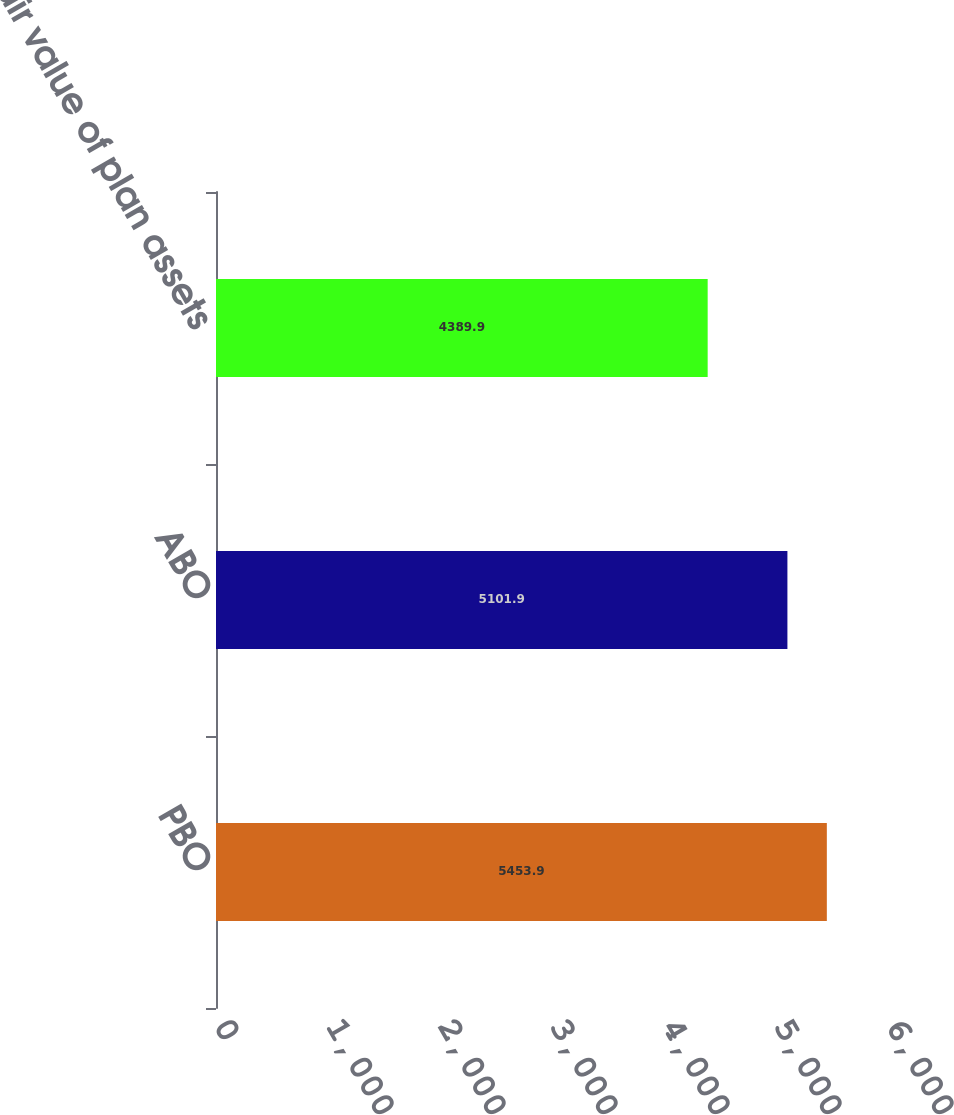Convert chart. <chart><loc_0><loc_0><loc_500><loc_500><bar_chart><fcel>PBO<fcel>ABO<fcel>Fair value of plan assets<nl><fcel>5453.9<fcel>5101.9<fcel>4389.9<nl></chart> 